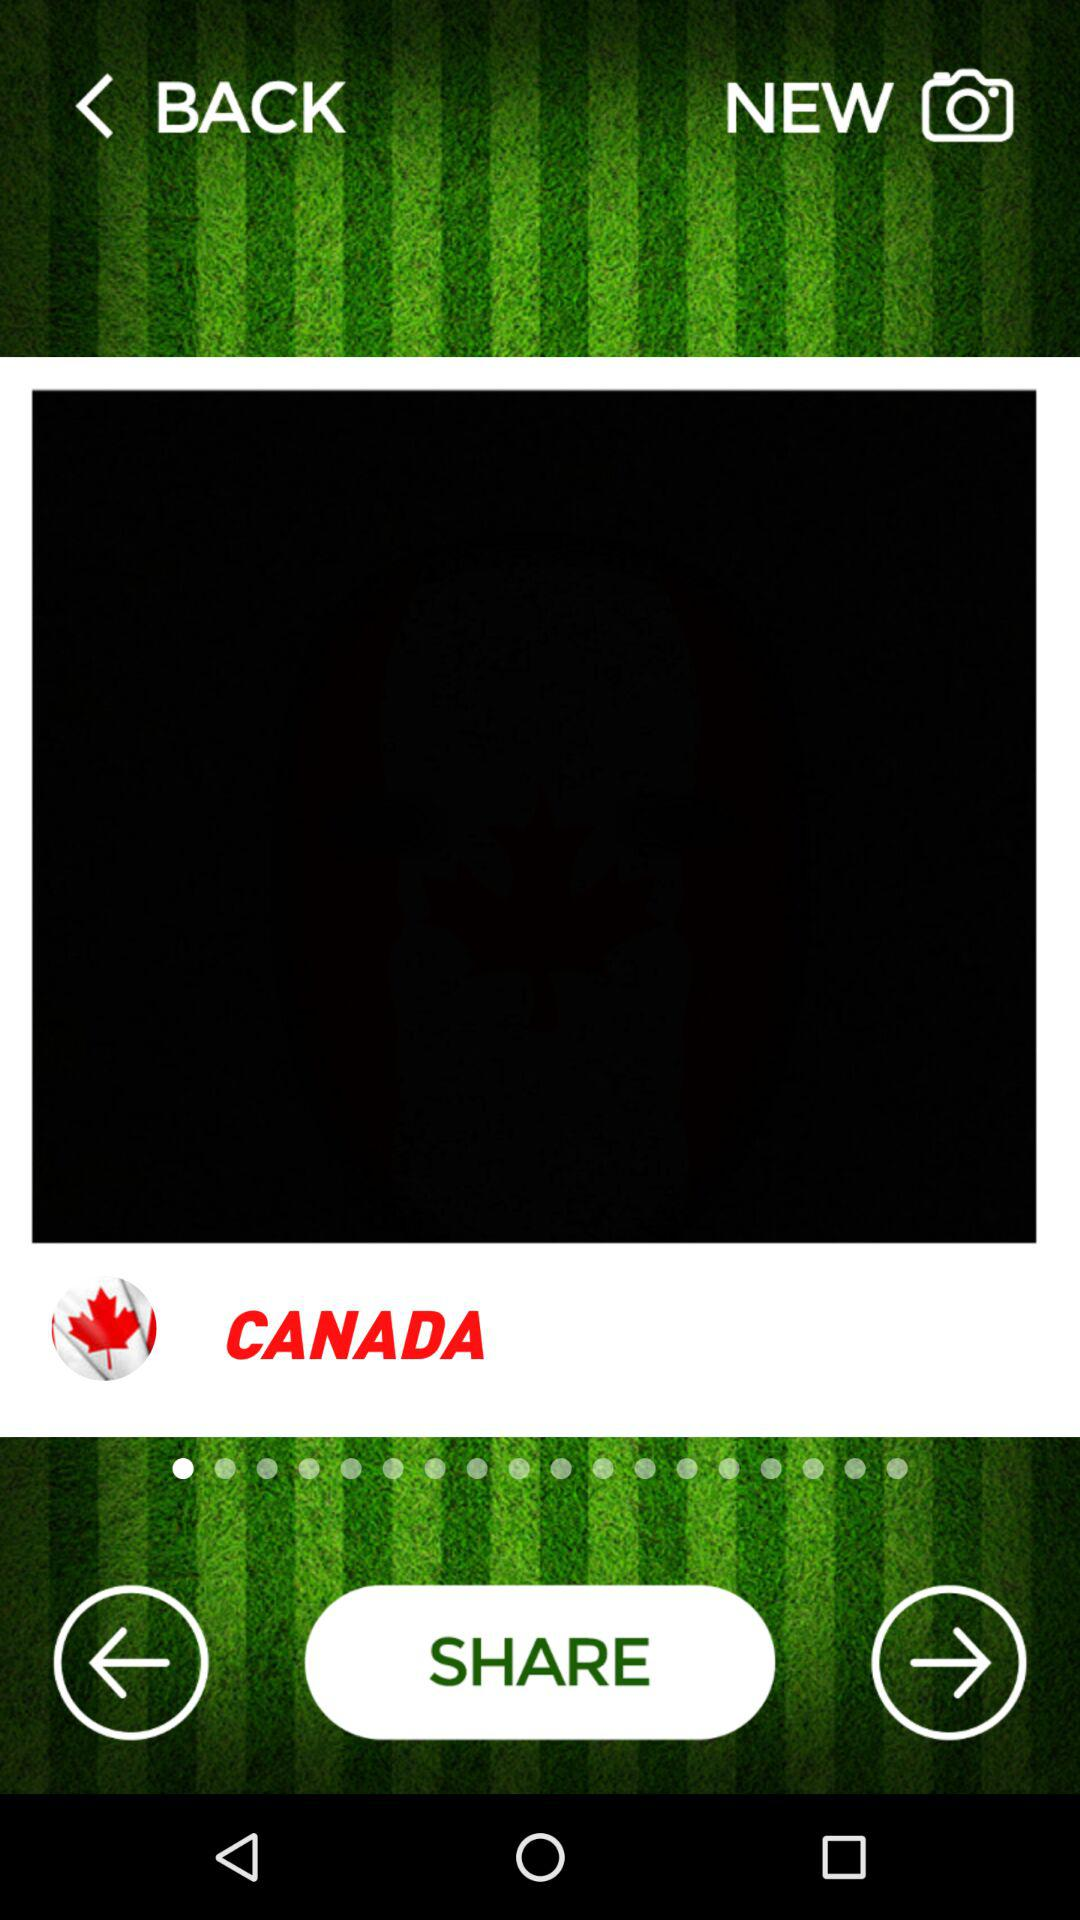What is the current location? The current location is Canada. 